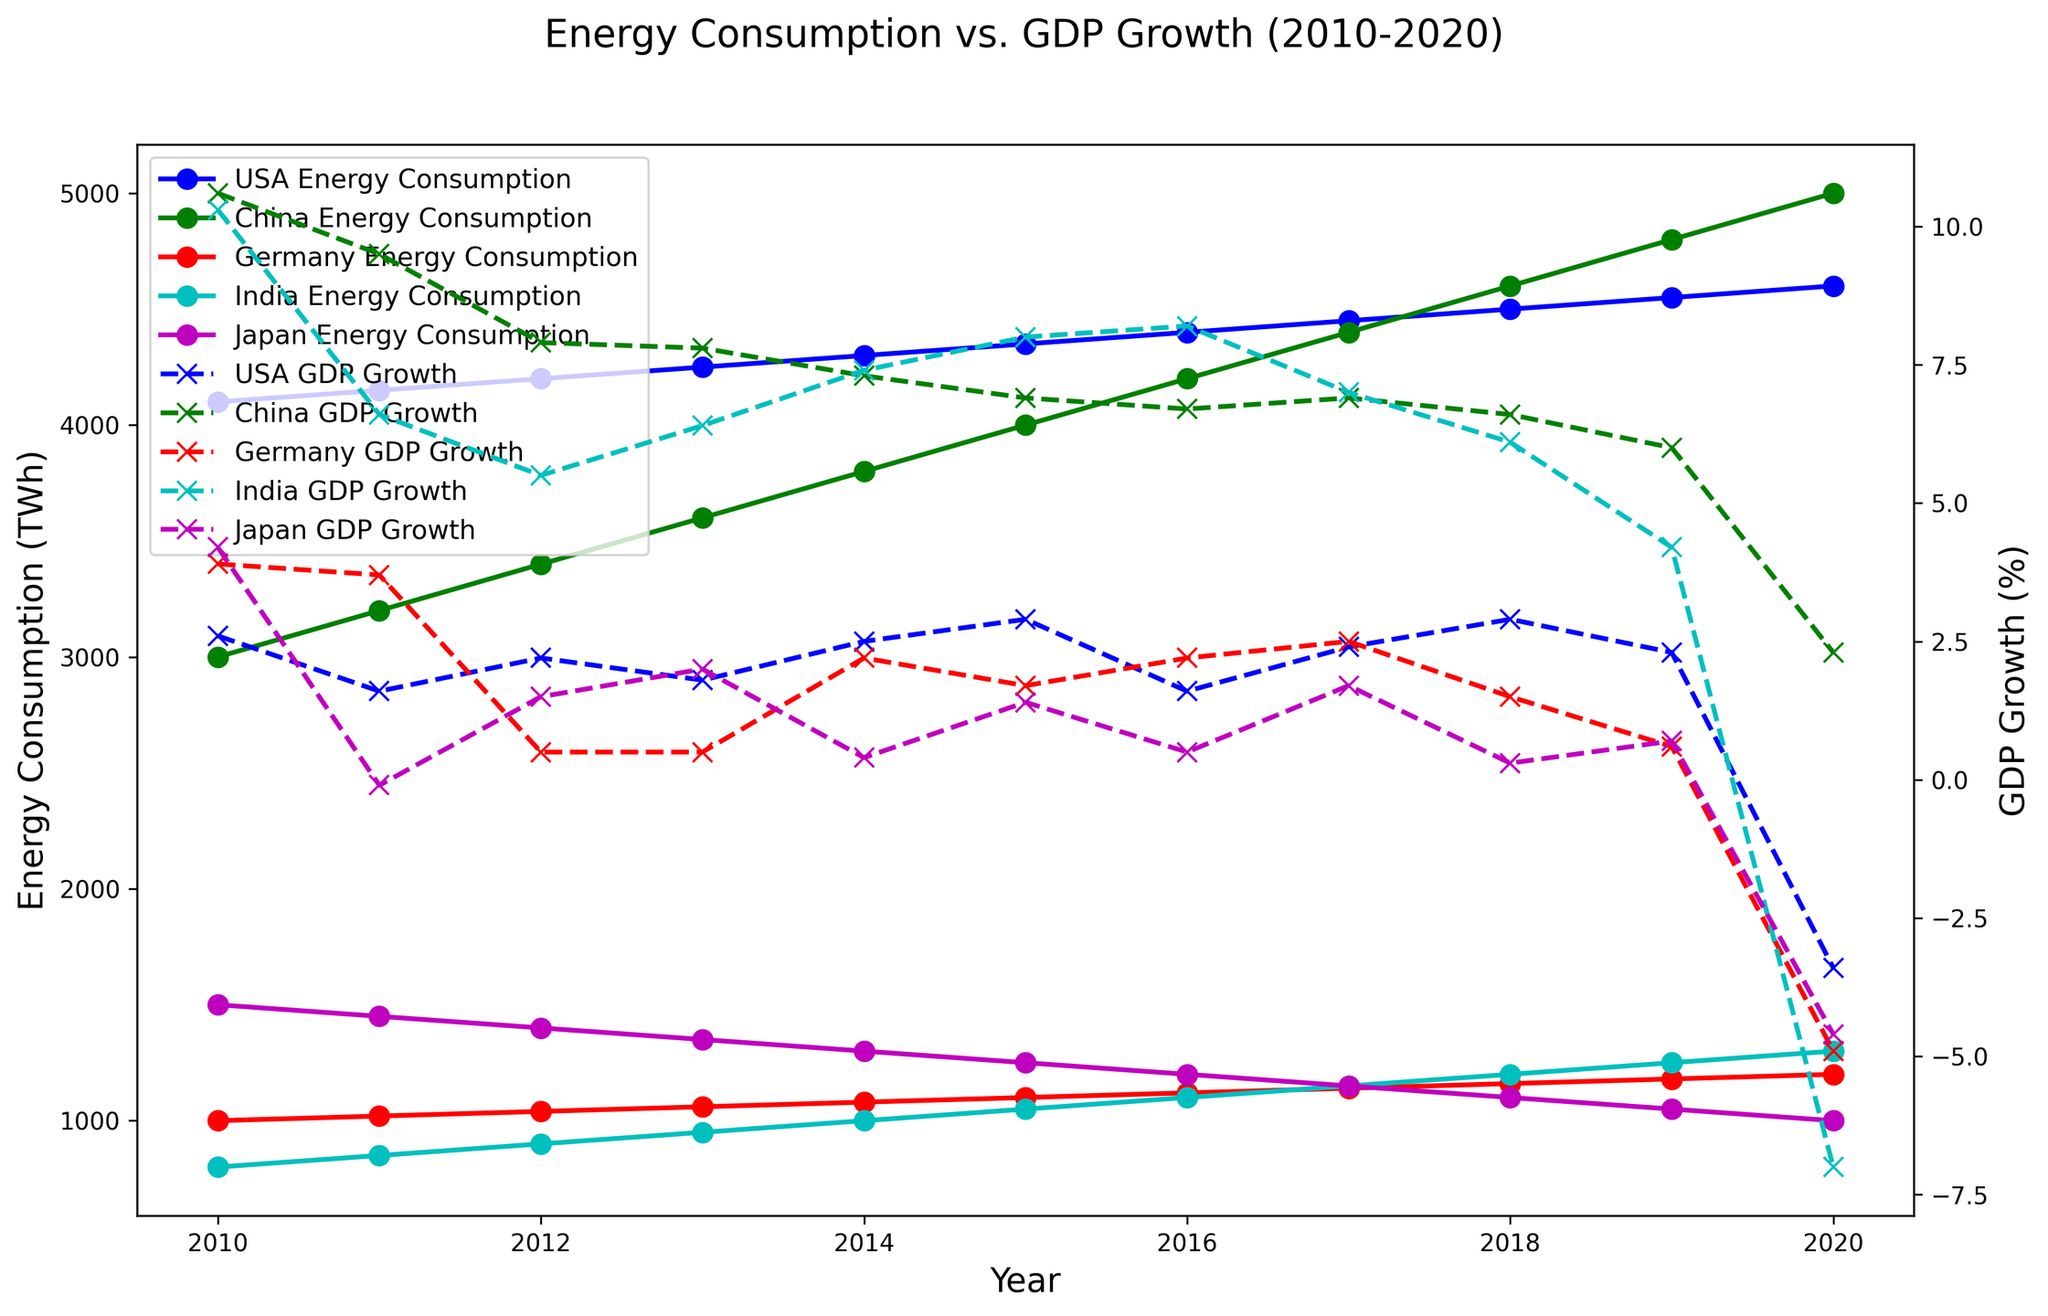Which country had the highest energy consumption in 2020? By examining the vertical lengths of the lines representing energy consumption in 2020, we observe that the USA line is the highest among all countries.
Answer: USA Which country experienced the highest GDP growth in 2010? By looking at the end points of the dashed lines representing GDP growth in 2010, we see that China had the highest end point.
Answer: China Compare the GDP growth rates of USA and Germany in 2019. Which one is higher? By comparing the end points of the dashed lines for USA and Germany in 2019, it is visible that the USA's line is higher than Germany’s.
Answer: USA Which country's energy consumption shows a declining trend over the period of 2010 to 2020? By following the solid lines across years, it is apparent that Japan's energy consumption decreases steadily throughout the period.
Answer: Japan Between which two consecutive years did China have the largest increase in energy consumption? By examining the increments in the heights of the lines for China, the most significant increase happens between 2019 and 2020.
Answer: 2019-2020 How did India’s GDP growth compare between 2019 and 2020? By comparing the end points of the dashed lines for India in 2019 and 2020, the GDP growth decreases significantly from 4.2% in 2019 to -7.0% in 2020.
Answer: It significantly decreased Which country had the lowest energy consumption in 2010? By comparing the starting points of the solid lines for all countries at 2010, Germany's line is the lowest, indicating the lowest energy consumption.
Answer: Germany What visual trend can be noted for the USA's energy consumption from 2010 to 2020? Following the line for USA energy consumption year by year, it shows a steady increase throughout the decade without any decline.
Answer: Steady increase Which country had the highest GDP growth during the period of 2010 to 2020? Observing the dashed lines throughout years, China maintains the highest overall GDP growth rates, with peak values notably higher than other countries.
Answer: China What is the relationship between Japan’s energy consumption and GDP growth from 2010 to 2020? By observing Japan’s lines, a decreasing trend in energy consumption correlates with an overall decrease in GDP growth over the years.
Answer: Both decreased 